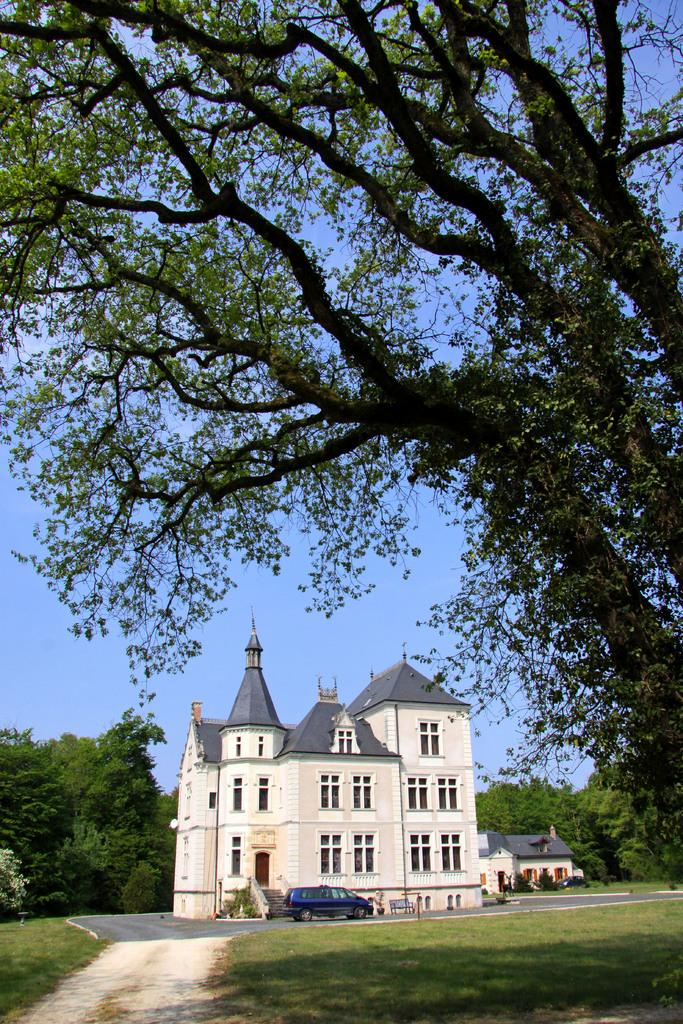What type of structure is visible in the image? There is a building in the image. Are there any residential structures in the image? Yes, there are houses in the image. What type of natural elements can be seen in the image? There are trees, plants, and grass in the image. Can you describe the landscape in the image? The landscape includes trees, plants, and grass, suggesting a natural setting. What is parked in front of the building? There is a car in front of the building. What type of tin can be seen in the image? There is no tin present in the image. Is there a knife visible in the image? There is no knife visible in the image. 